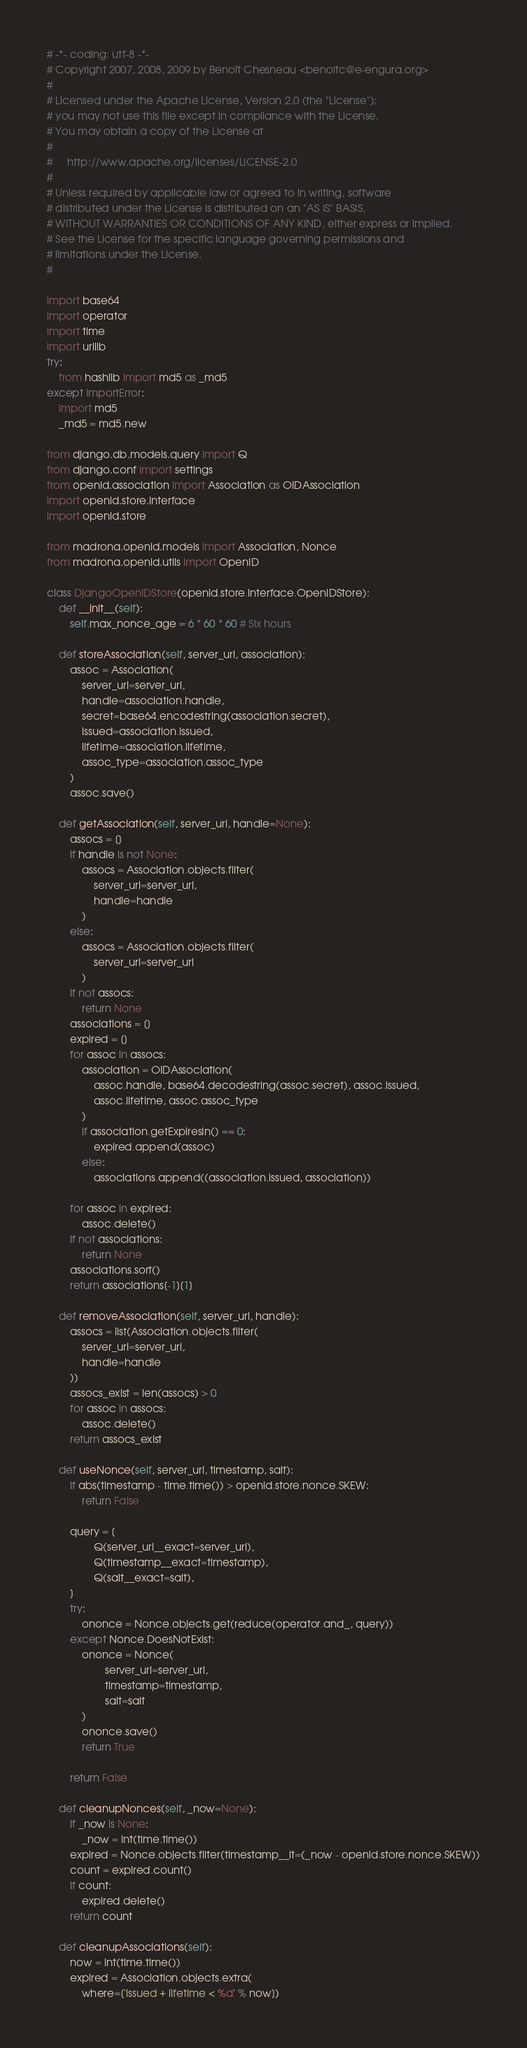<code> <loc_0><loc_0><loc_500><loc_500><_Python_># -*- coding: utf-8 -*-
# Copyright 2007, 2008, 2009 by Benoît Chesneau <benoitc@e-engura.org>
# 
# Licensed under the Apache License, Version 2.0 (the "License");
# you may not use this file except in compliance with the License.
# You may obtain a copy of the License at
#
#     http://www.apache.org/licenses/LICENSE-2.0
#
# Unless required by applicable law or agreed to in writing, software
# distributed under the License is distributed on an "AS IS" BASIS,
# WITHOUT WARRANTIES OR CONDITIONS OF ANY KIND, either express or implied.
# See the License for the specific language governing permissions and
# limitations under the License.
#

import base64
import operator
import time
import urllib
try:
    from hashlib import md5 as _md5
except ImportError:
    import md5
    _md5 = md5.new

from django.db.models.query import Q
from django.conf import settings
from openid.association import Association as OIDAssociation
import openid.store.interface
import openid.store

from madrona.openid.models import Association, Nonce
from madrona.openid.utils import OpenID

class DjangoOpenIDStore(openid.store.interface.OpenIDStore):
    def __init__(self):
        self.max_nonce_age = 6 * 60 * 60 # Six hours

    def storeAssociation(self, server_url, association):
        assoc = Association(
            server_url=server_url,
            handle=association.handle,
            secret=base64.encodestring(association.secret),
            issued=association.issued,
            lifetime=association.lifetime,
            assoc_type=association.assoc_type
        )
        assoc.save()

    def getAssociation(self, server_url, handle=None):
        assocs = []
        if handle is not None:
            assocs = Association.objects.filter(
                server_url=server_url, 
                handle=handle
            )
        else:
            assocs = Association.objects.filter(
                server_url=server_url
            )
        if not assocs:
            return None
        associations = []
        expired = []
        for assoc in assocs:
            association = OIDAssociation(
                assoc.handle, base64.decodestring(assoc.secret), assoc.issued,
                assoc.lifetime, assoc.assoc_type
            )
            if association.getExpiresIn() == 0:
                expired.append(assoc)
            else:
                associations.append((association.issued, association))

        for assoc in expired:
            assoc.delete()
        if not associations:
            return None
        associations.sort()
        return associations[-1][1]

    def removeAssociation(self, server_url, handle):
        assocs = list(Association.objects.filter(
            server_url=server_url, 
            handle=handle
        ))
        assocs_exist = len(assocs) > 0
        for assoc in assocs:
            assoc.delete()
        return assocs_exist

    def useNonce(self, server_url, timestamp, salt):
        if abs(timestamp - time.time()) > openid.store.nonce.SKEW:
            return False

        query = [
                Q(server_url__exact=server_url),
                Q(timestamp__exact=timestamp),
                Q(salt__exact=salt),
        ]
        try:
            ononce = Nonce.objects.get(reduce(operator.and_, query))
        except Nonce.DoesNotExist:
            ononce = Nonce(
                    server_url=server_url,
                    timestamp=timestamp,
                    salt=salt
            )
            ononce.save()
            return True

        return False

    def cleanupNonces(self, _now=None):
        if _now is None:
            _now = int(time.time())
        expired = Nonce.objects.filter(timestamp__lt=(_now - openid.store.nonce.SKEW))
        count = expired.count()
        if count:
            expired.delete()
        return count

    def cleanupAssociations(self):
        now = int(time.time())
        expired = Association.objects.extra(
            where=['issued + lifetime < %d' % now])</code> 